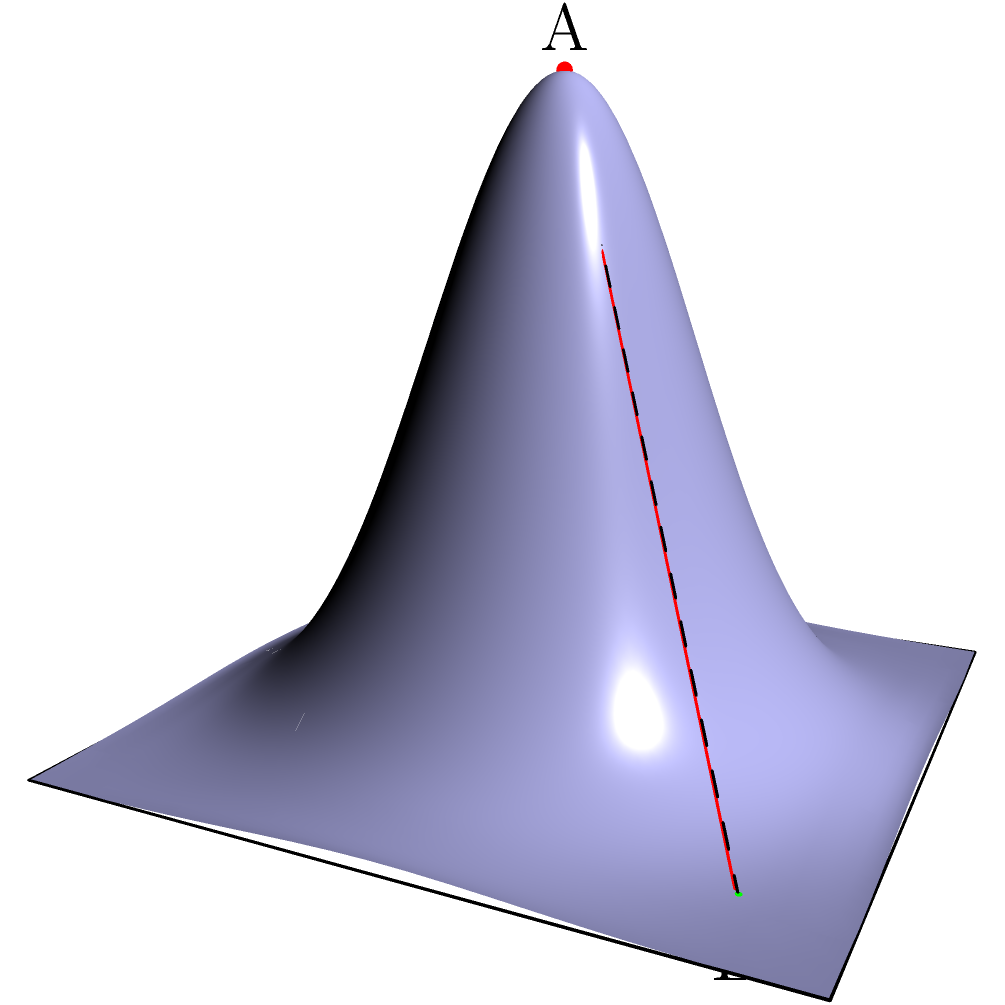In an emergency ascent scenario from point A to point B on the ocean floor, which path would be the shortest: the direct path (red line) or following the ocean floor's contour (dashed line)? Calculate the length difference between these two paths. Let's approach this step-by-step:

1) First, we need to identify the coordinates of points A and B:
   A: (0, 0, 2)
   B: (1.5, 1.5, 0)

2) To calculate the length of the direct path (red line):
   We can use the 3D distance formula: $$d = \sqrt{(x_2-x_1)^2 + (y_2-y_1)^2 + (z_2-z_1)^2}$$
   $$d_{direct} = \sqrt{(1.5-0)^2 + (1.5-0)^2 + (0-2)^2} = \sqrt{2.25 + 2.25 + 4} = \sqrt{8.5} \approx 2.92$$

3) For the contour path (dashed line), we need to calculate it in two parts:
   a) Vertical descent from A to the surface point above B
   b) Distance along the surface to B

4) The surface height at B can be calculated using the given function:
   $$z = 2e^{-x^2-y^2}$$
   At (1.5, 1.5): $$z = 2e^{-1.5^2-1.5^2} \approx 0.0197$$

5) Now we can calculate the two parts of the contour path:
   a) Vertical descent: $2 - 0.0197 = 1.9803$
   b) Surface distance: $$\sqrt{1.5^2 + 1.5^2} = \sqrt{4.5} \approx 2.12$$

6) Total contour path length: $1.9803 + 2.12 = 4.1003$

7) The difference in length:
   $4.1003 - 2.92 = 1.1803$

Therefore, the direct path is shorter by approximately 1.18 units.
Answer: Direct path; 1.18 units shorter 